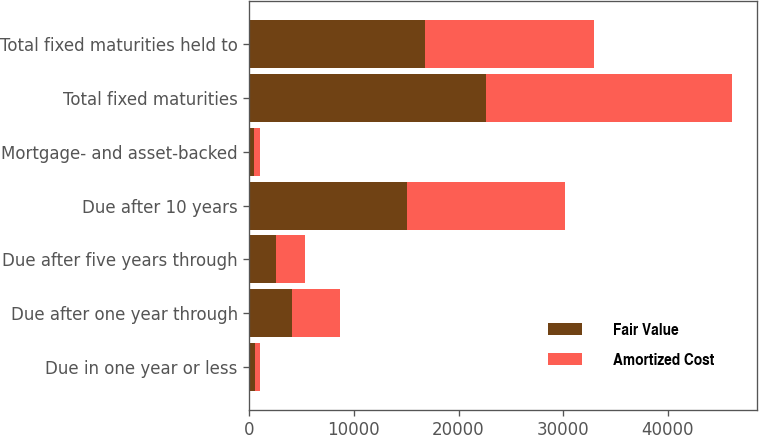Convert chart to OTSL. <chart><loc_0><loc_0><loc_500><loc_500><stacked_bar_chart><ecel><fcel>Due in one year or less<fcel>Due after one year through<fcel>Due after five years through<fcel>Due after 10 years<fcel>Mortgage- and asset-backed<fcel>Total fixed maturities<fcel>Total fixed maturities held to<nl><fcel>Fair Value<fcel>503<fcel>4078<fcel>2524<fcel>15056<fcel>489<fcel>22650<fcel>16799<nl><fcel>Amortized Cost<fcel>508<fcel>4608<fcel>2814<fcel>15105<fcel>497<fcel>23532<fcel>16171<nl></chart> 